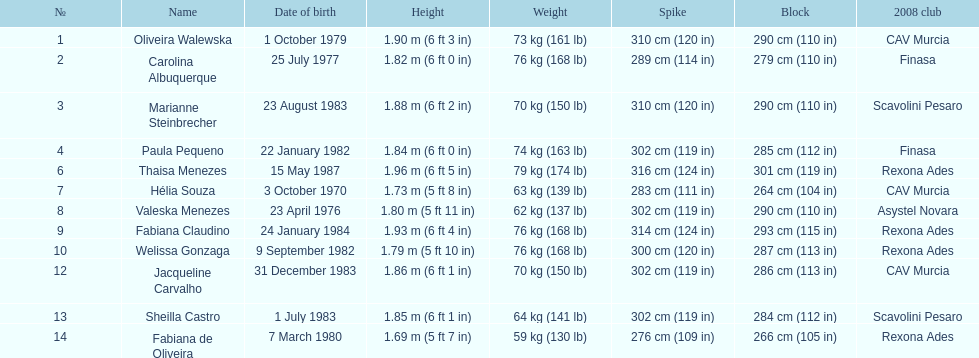Identify the player with a height of merely 5 feet 7 inches. Fabiana de Oliveira. 